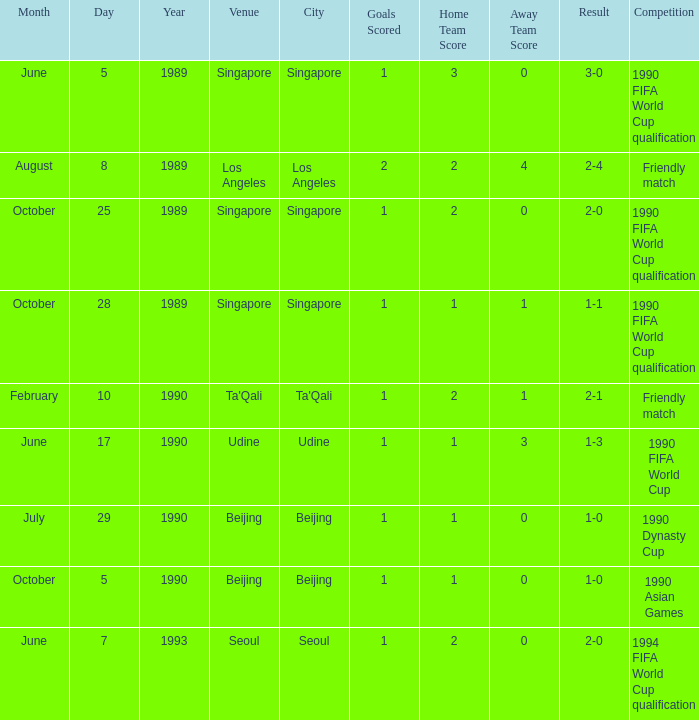Write the full table. {'header': ['Month', 'Day', 'Year', 'Venue', 'City', 'Goals Scored', 'Home Team Score', 'Away Team Score', 'Result', 'Competition'], 'rows': [['June', '5', '1989', 'Singapore', 'Singapore', '1', '3', '0', '3-0', '1990 FIFA World Cup qualification'], ['August', '8', '1989', 'Los Angeles', 'Los Angeles', '2', '2', '4', '2-4', 'Friendly match'], ['October', '25', '1989', 'Singapore', 'Singapore', '1', '2', '0', '2-0', '1990 FIFA World Cup qualification'], ['October', '28', '1989', 'Singapore', 'Singapore', '1', '1', '1', '1-1', '1990 FIFA World Cup qualification'], ['February', '10', '1990', "Ta'Qali", "Ta'Qali", '1', '2', '1', '2-1', 'Friendly match'], ['June', '17', '1990', 'Udine', 'Udine', '1', '1', '3', '1-3', '1990 FIFA World Cup'], ['July', '29', '1990', 'Beijing', 'Beijing', '1', '1', '0', '1-0', '1990 Dynasty Cup'], ['October', '5', '1990', 'Beijing', 'Beijing', '1', '1', '0', '1-0', '1990 Asian Games'], ['June', '7', '1993', 'Seoul', 'Seoul', '1', '2', '0', '2-0', '1994 FIFA World Cup qualification']]} At which location did the 1990 asian games take place? Beijing. 